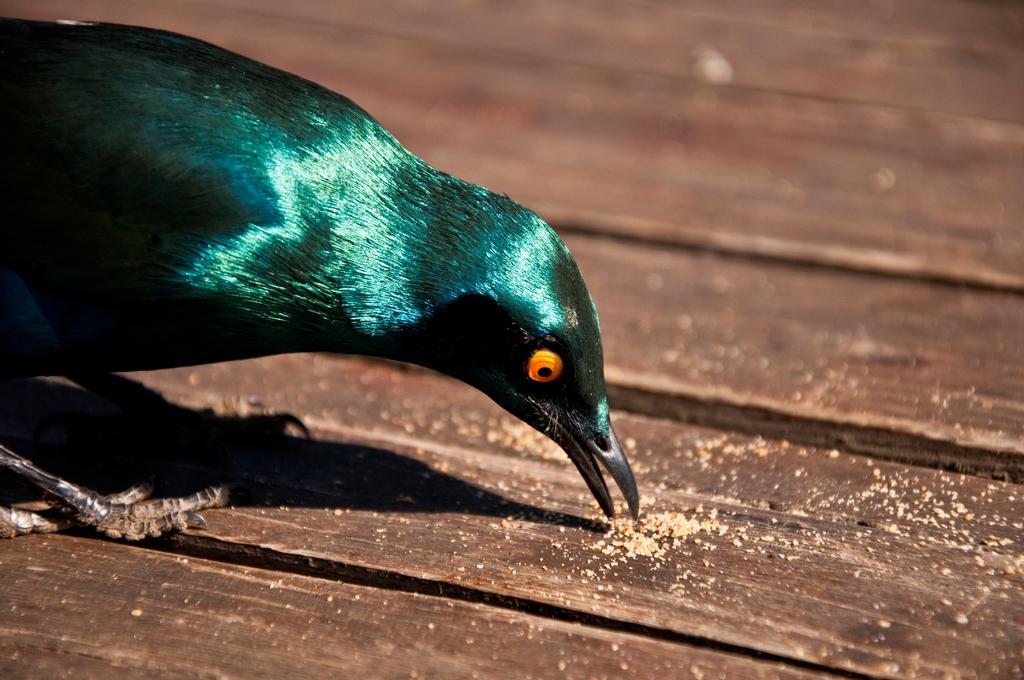In one or two sentences, can you explain what this image depicts? There is a bird on the left side of the image on a wooden surface. 